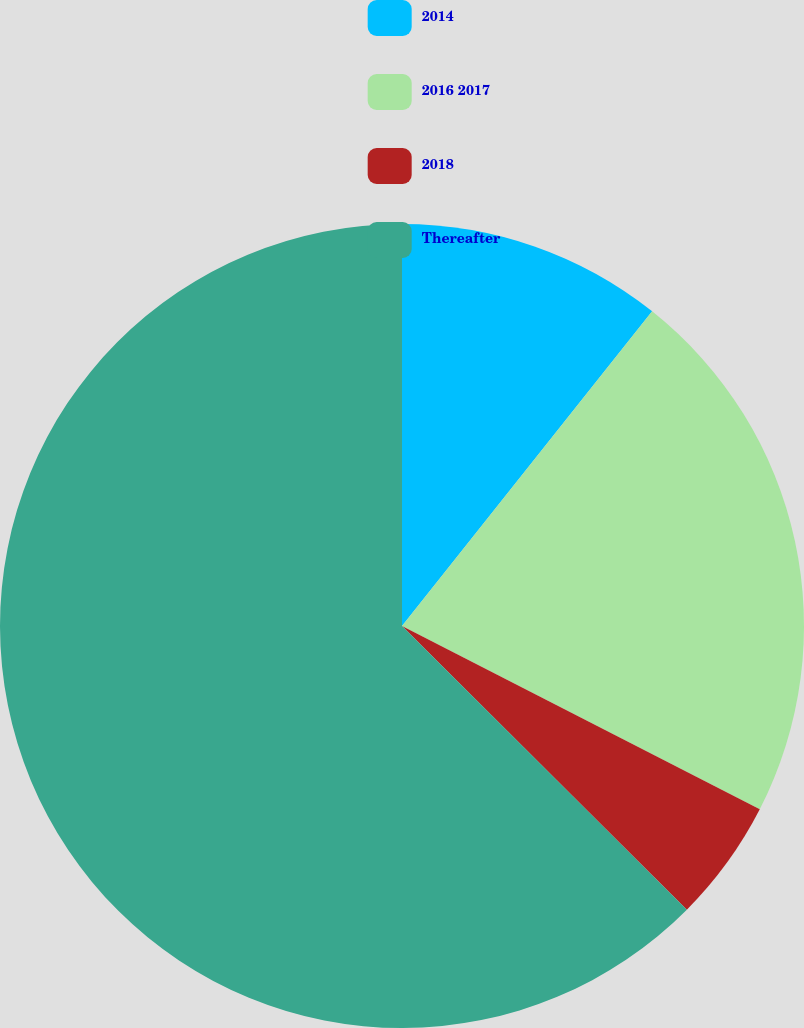Convert chart. <chart><loc_0><loc_0><loc_500><loc_500><pie_chart><fcel>2014<fcel>2016 2017<fcel>2018<fcel>Thereafter<nl><fcel>10.69%<fcel>21.85%<fcel>4.93%<fcel>62.54%<nl></chart> 